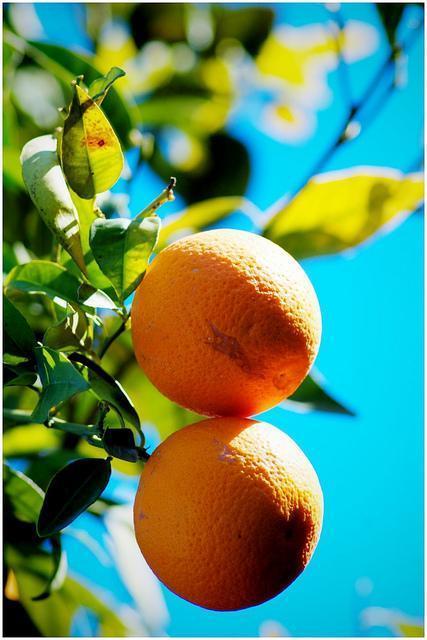How many oranges?
Give a very brief answer. 2. How many oranges are there?
Give a very brief answer. 2. How many giraffes are pictured?
Give a very brief answer. 0. 